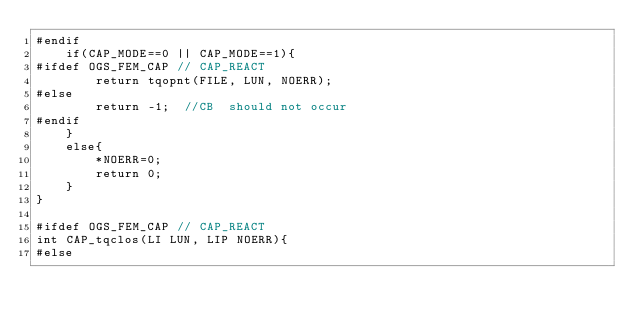<code> <loc_0><loc_0><loc_500><loc_500><_C++_>#endif
	if(CAP_MODE==0 || CAP_MODE==1){
#ifdef OGS_FEM_CAP // CAP_REACT
		return tqopnt(FILE, LUN, NOERR);
#else
        return -1;  //CB  should not occur
#endif
    }
	else{
		*NOERR=0;
		return 0;
	}
}

#ifdef OGS_FEM_CAP // CAP_REACT
int CAP_tqclos(LI LUN, LIP NOERR){
#else</code> 